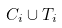<formula> <loc_0><loc_0><loc_500><loc_500>C _ { i } \cup T _ { i }</formula> 